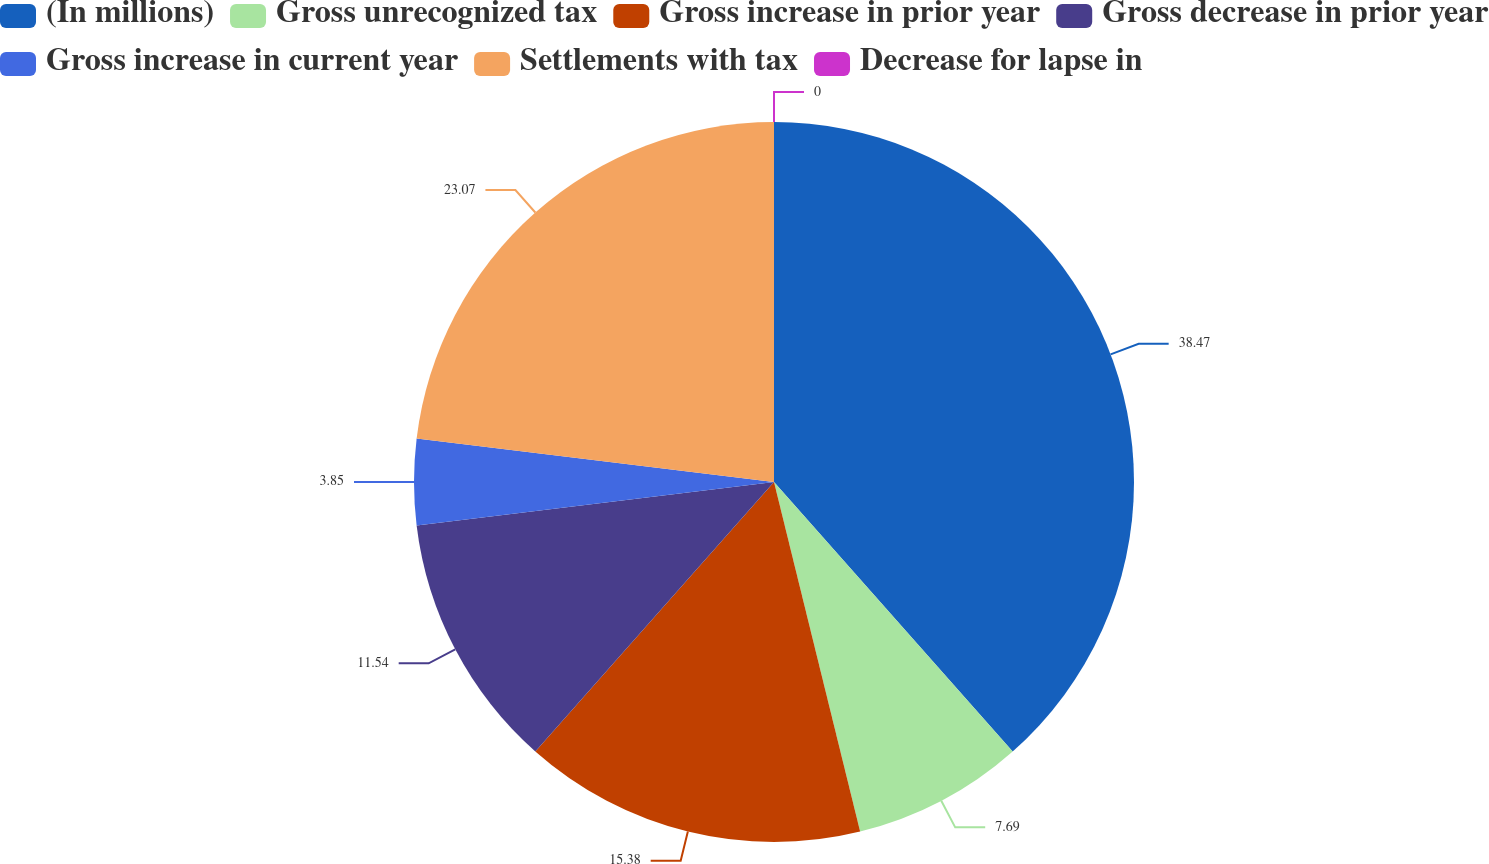Convert chart to OTSL. <chart><loc_0><loc_0><loc_500><loc_500><pie_chart><fcel>(In millions)<fcel>Gross unrecognized tax<fcel>Gross increase in prior year<fcel>Gross decrease in prior year<fcel>Gross increase in current year<fcel>Settlements with tax<fcel>Decrease for lapse in<nl><fcel>38.46%<fcel>7.69%<fcel>15.38%<fcel>11.54%<fcel>3.85%<fcel>23.07%<fcel>0.0%<nl></chart> 